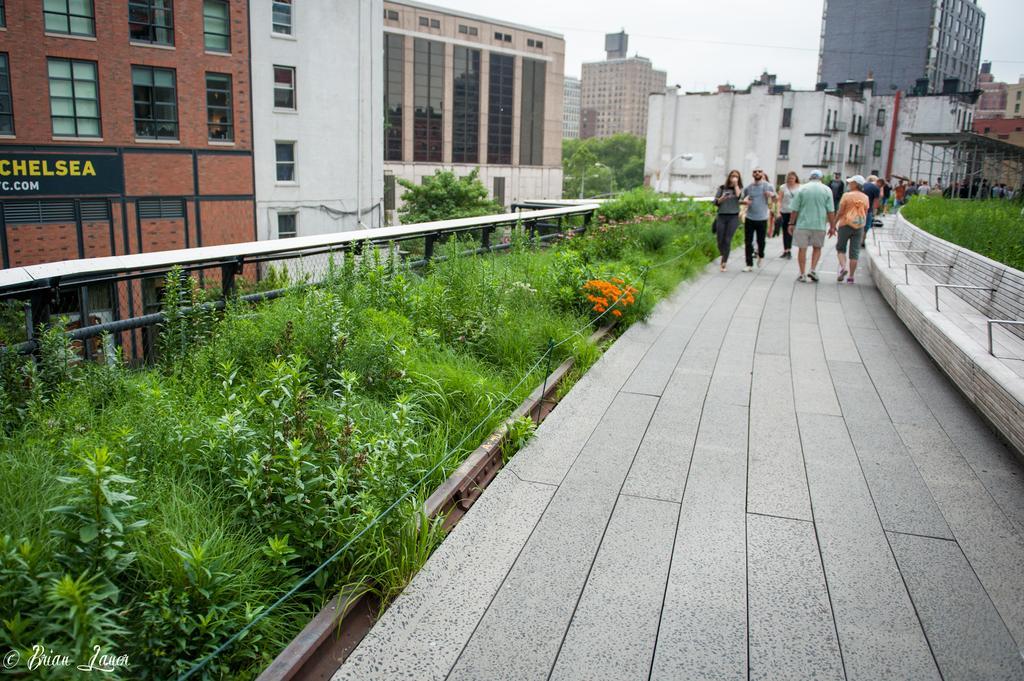How would you summarize this image in a sentence or two? In this picture we can see a group of men and women walking on the pedestal area. Beside we can see some green plants. In the background there are some buildings. 